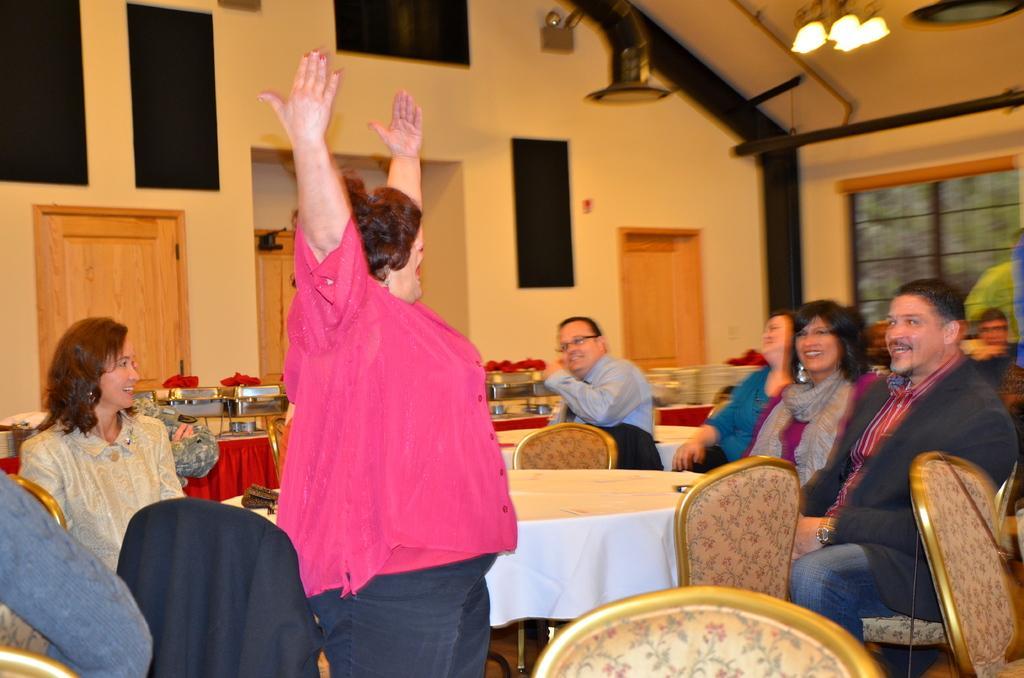Can you describe this image briefly? Here is a dining table covered with a white cloth, chairs are placed around it. To the right most, we find a man with black blazer wearing watch is laughing and sitting on the chair. To the right of him, we find a woman wearing shrug and laughing. To the right of this woman, we see other woman who is wearing blue t-shirt is sitting on the chair and also laughing. Next to next to this woman, we see man wearing blue shirt and also wearing spectacles, is laughing and in the middle we see woman in pink top and in blue jeans is laughing and she might be either dancing or acting. To the left most, we see woman sitting on the chair and laughing. Totally there are one two three four five six seven, seven seven people. Among them four are women and the remaining three are men. To the to the right most, we find a window from which we can see trees. Behind this people, we see vessels,fruits and everything served over here. Behind this table we see walls and also the doors which are made of wood. One two three, we see three doors. 